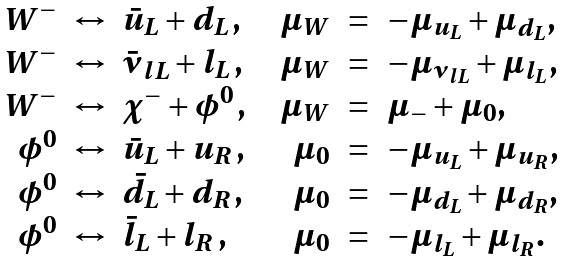Convert formula to latex. <formula><loc_0><loc_0><loc_500><loc_500>\begin{array} { r c l c r c l } W ^ { - } & \leftrightarrow & \bar { u } _ { L } + d _ { L } \, , & & \mu _ { W } & = & - \mu _ { u _ { L } } + \mu _ { d _ { L } } , \\ W ^ { - } & \leftrightarrow & \bar { \nu } _ { l L } + l _ { L } \, , & & \mu _ { W } & = & - \mu _ { \nu _ { l L } } + \mu _ { l _ { L } } , \\ W ^ { - } & \leftrightarrow & \chi ^ { - } + \phi ^ { 0 } \, , & & \mu _ { W } & = & \mu _ { - } + \mu _ { 0 } , \\ \phi ^ { 0 } & \leftrightarrow & \bar { u } _ { L } + u _ { R } \, , & & \mu _ { 0 } & = & - \mu _ { u _ { L } } + \mu _ { u _ { R } } , \\ \phi ^ { 0 } & \leftrightarrow & \bar { d } _ { L } + d _ { R } \, , & & \mu _ { 0 } & = & - \mu _ { d _ { L } } + \mu _ { d _ { R } } , \\ \phi ^ { 0 } & \leftrightarrow & \bar { l } _ { L } + l _ { R } \, , & & \mu _ { 0 } & = & - \mu _ { l _ { L } } + \mu _ { l _ { R } } . \end{array}</formula> 